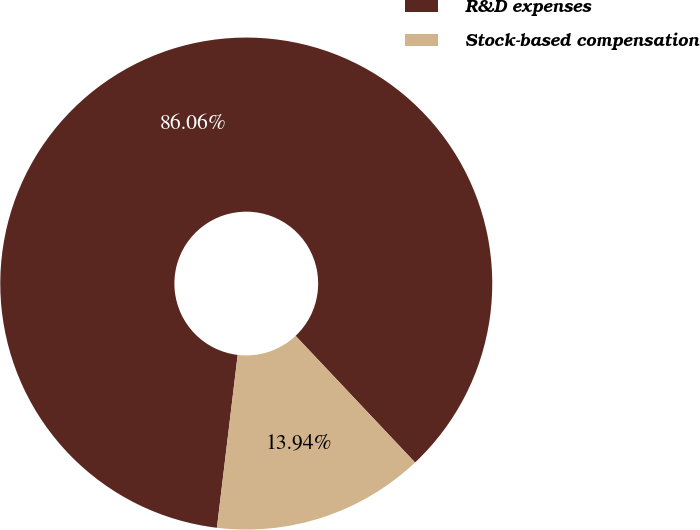Convert chart. <chart><loc_0><loc_0><loc_500><loc_500><pie_chart><fcel>R&D expenses<fcel>Stock-based compensation<nl><fcel>86.06%<fcel>13.94%<nl></chart> 